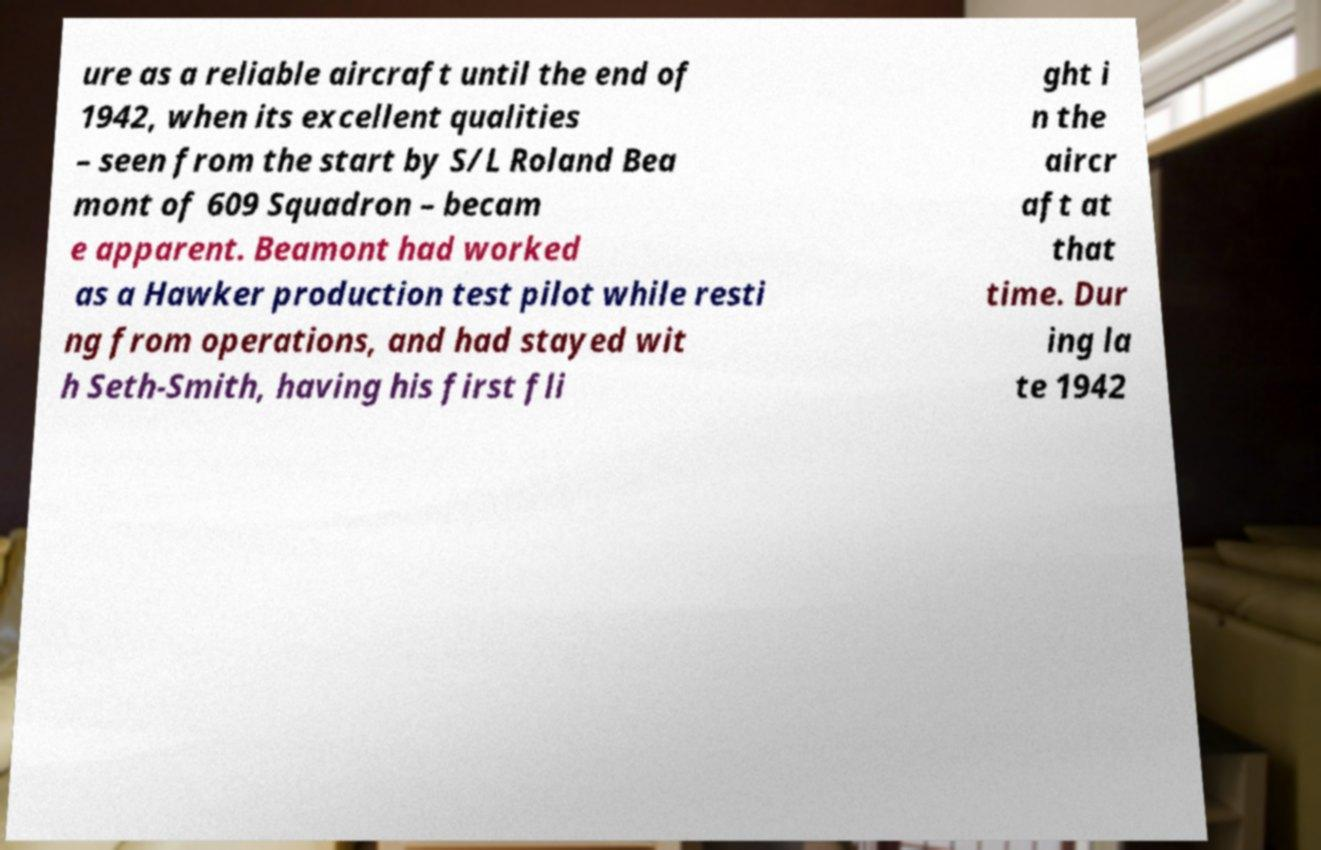Please read and relay the text visible in this image. What does it say? ure as a reliable aircraft until the end of 1942, when its excellent qualities – seen from the start by S/L Roland Bea mont of 609 Squadron – becam e apparent. Beamont had worked as a Hawker production test pilot while resti ng from operations, and had stayed wit h Seth-Smith, having his first fli ght i n the aircr aft at that time. Dur ing la te 1942 